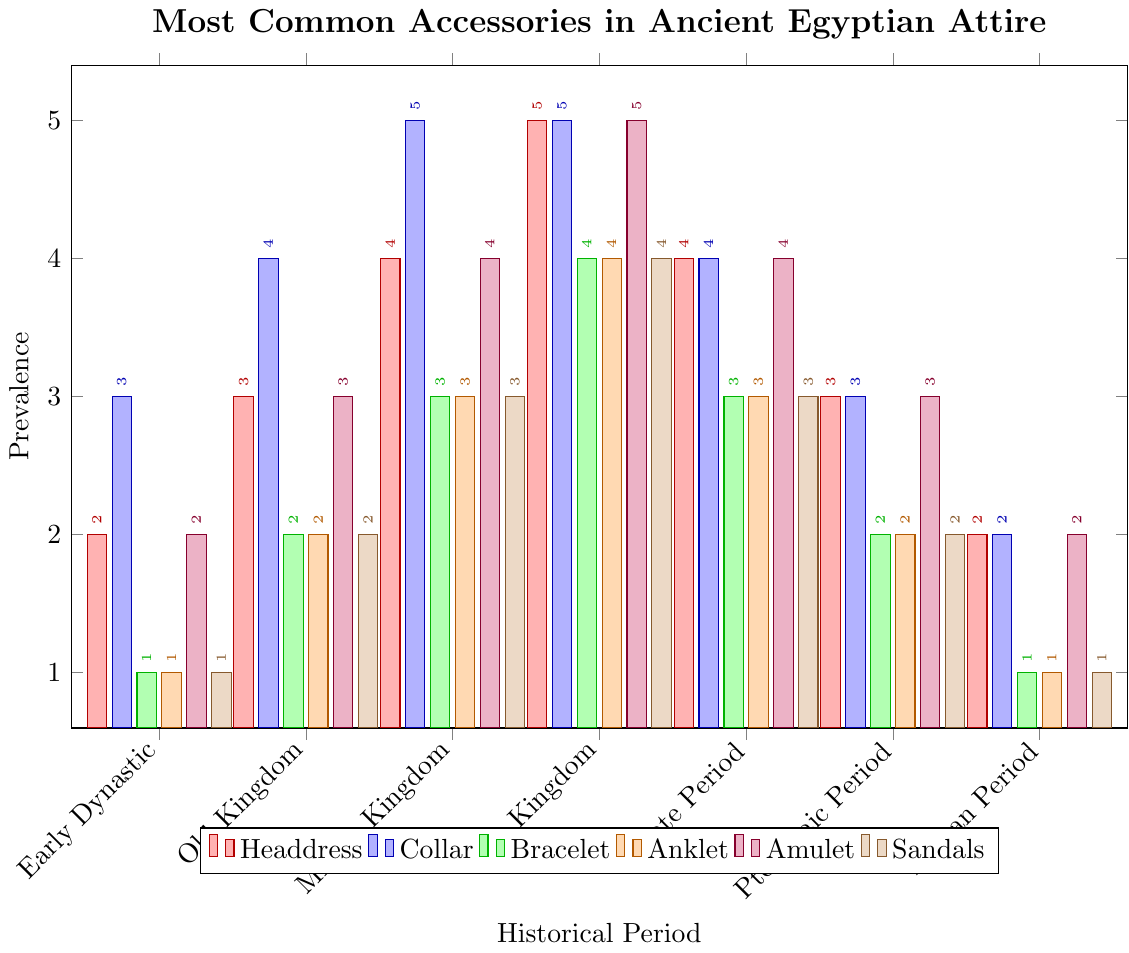Which historical period had the highest prevalence of headdress? The height of the headdress bar is tallest in the New Kingdom period, indicating the highest prevalence.
Answer: New Kingdom Which accessory had the highest prevalence in the Late Period? By examining the bar heights for the Late Period, the collar, headdress, and amulet all have the highest bar height of 4.
Answer: Collar, Headdress, Amulet In which periods did amulets have a prevalence equal to 3? Check the height of the amulet bars: they indicate a prevalence of 3 in the Old Kingdom, Late Period, and Ptolemaic Period.
Answer: Old Kingdom, Late Period, Ptolemaic Period Which accessory consistently had increasing prevalence from Early Dynastic to New Kingdom? Examine the height of each bar from Early Dynastic to New Kingdom. The headdress, collar, bracelet, anklet, and amulet all show consistent increases.
Answer: Headdress, Collar, Bracelet, Anklet, Amulet What is the average prevalence of bracelets across all periods? Sum the prevalence of bracelets for all periods (1+2+3+4+3+2+1) and divide by the number of periods (7). Calculation: (1+2+3+4+3+2+1)/7 = 2.29
Answer: 2.29 Was there any period where the prevalence of sandals equaled the prevalence of anklets? Compare the bar heights for sandals and anklets; they are equal in every period, with both having the same values throughout: (1, 2, 3, 4, 3, 2, 1).
Answer: All periods Compare the prevalence of collars and headdresses in the Middle Kingdom. Which is more prevalent? Look at the bar heights in the Middle Kingdom: the collar bar is taller than the headdress bar (5 vs 4).
Answer: Collar What is the sum of headdress prevalence in the Old Kingdom and Ptolemaic Period? Add the prevalence of headdresses in these periods: 3 (Old Kingdom) + 3 (Ptolemaic Period) = 6.
Answer: 6 Among the accessories, which one had the least variation in prevalence across the historical periods? Variation is smallest in sandals, as the bars have the same pattern across periods (increments and decrements by 1) from 1 to 4 and back down to 1.
Answer: Sandals 